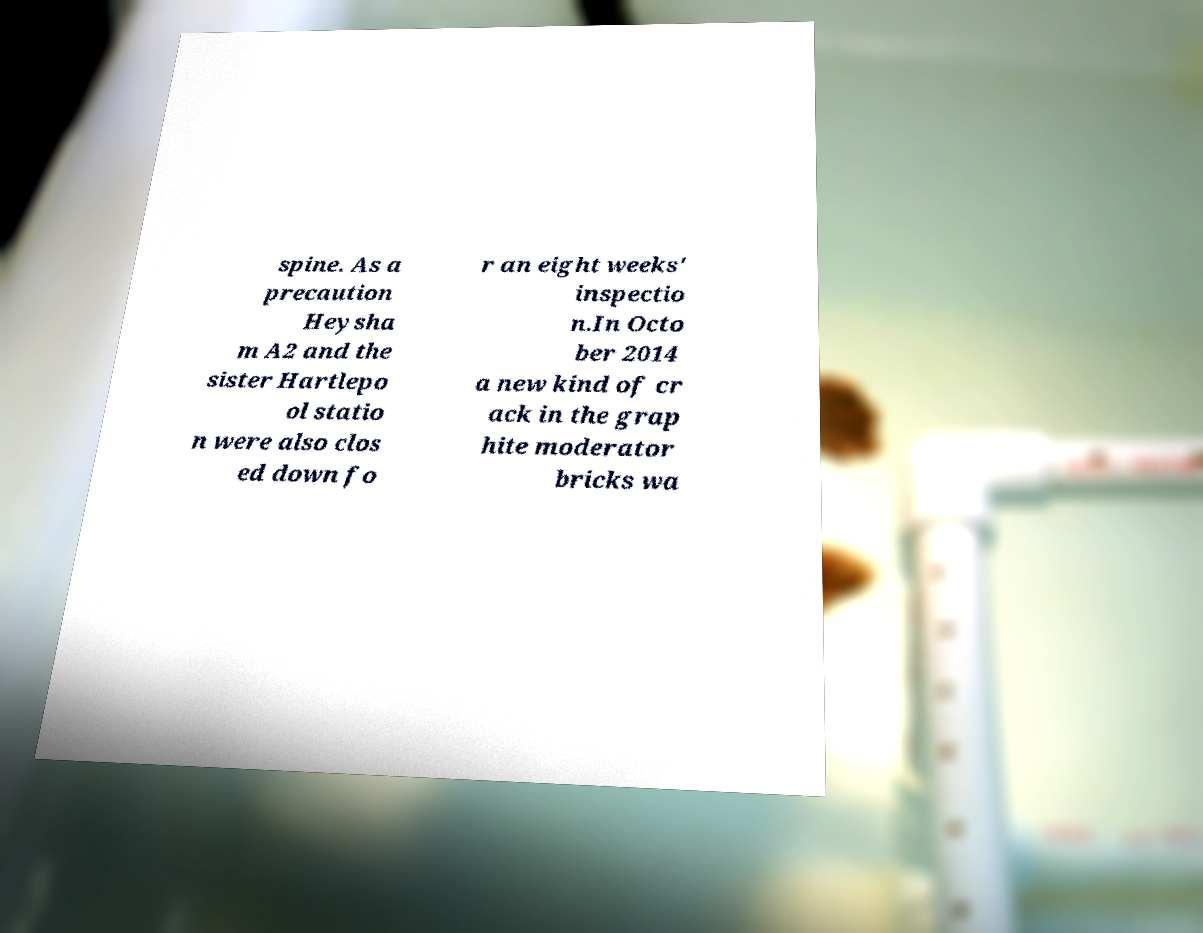Could you extract and type out the text from this image? spine. As a precaution Heysha m A2 and the sister Hartlepo ol statio n were also clos ed down fo r an eight weeks' inspectio n.In Octo ber 2014 a new kind of cr ack in the grap hite moderator bricks wa 